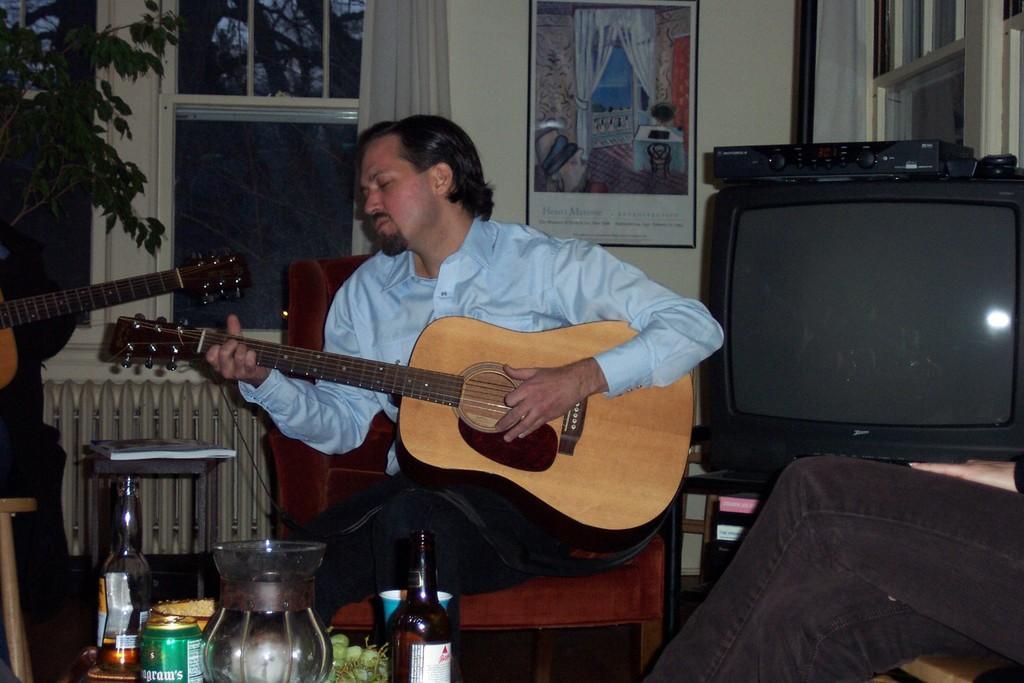How would you summarize this image in a sentence or two? This is a picture of a man in blue shirt holding a guitar and sitting on a chair on the write side of the man there is a television and left side of the man there is a person holding a guitar. Background of the man is a glass window, wall and photo frame. 